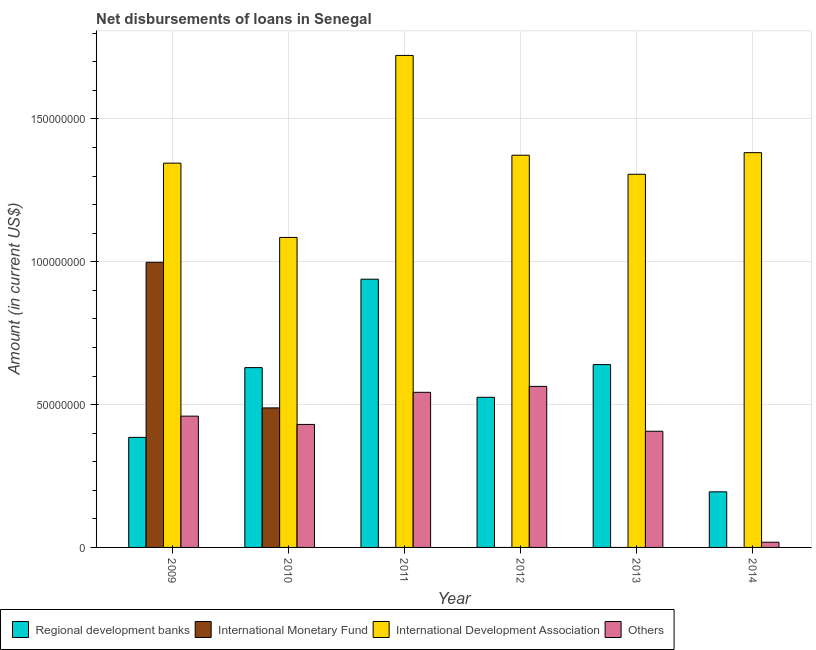Are the number of bars per tick equal to the number of legend labels?
Make the answer very short. No. What is the amount of loan disimbursed by international development association in 2009?
Provide a short and direct response. 1.35e+08. Across all years, what is the maximum amount of loan disimbursed by other organisations?
Your answer should be very brief. 5.64e+07. Across all years, what is the minimum amount of loan disimbursed by regional development banks?
Make the answer very short. 1.95e+07. What is the total amount of loan disimbursed by regional development banks in the graph?
Provide a succinct answer. 3.31e+08. What is the difference between the amount of loan disimbursed by regional development banks in 2012 and that in 2014?
Provide a succinct answer. 3.31e+07. What is the average amount of loan disimbursed by regional development banks per year?
Make the answer very short. 5.52e+07. In the year 2009, what is the difference between the amount of loan disimbursed by other organisations and amount of loan disimbursed by international monetary fund?
Offer a terse response. 0. What is the ratio of the amount of loan disimbursed by international development association in 2011 to that in 2014?
Keep it short and to the point. 1.25. Is the difference between the amount of loan disimbursed by other organisations in 2012 and 2014 greater than the difference between the amount of loan disimbursed by international monetary fund in 2012 and 2014?
Give a very brief answer. No. What is the difference between the highest and the second highest amount of loan disimbursed by international development association?
Offer a very short reply. 3.40e+07. What is the difference between the highest and the lowest amount of loan disimbursed by international development association?
Offer a very short reply. 6.37e+07. In how many years, is the amount of loan disimbursed by international development association greater than the average amount of loan disimbursed by international development association taken over all years?
Keep it short and to the point. 3. Is the sum of the amount of loan disimbursed by international development association in 2012 and 2014 greater than the maximum amount of loan disimbursed by other organisations across all years?
Offer a very short reply. Yes. Are all the bars in the graph horizontal?
Provide a succinct answer. No. How many years are there in the graph?
Provide a short and direct response. 6. What is the difference between two consecutive major ticks on the Y-axis?
Provide a succinct answer. 5.00e+07. Are the values on the major ticks of Y-axis written in scientific E-notation?
Keep it short and to the point. No. Does the graph contain any zero values?
Your response must be concise. Yes. Does the graph contain grids?
Offer a terse response. Yes. How are the legend labels stacked?
Offer a terse response. Horizontal. What is the title of the graph?
Keep it short and to the point. Net disbursements of loans in Senegal. Does "Coal" appear as one of the legend labels in the graph?
Give a very brief answer. No. What is the label or title of the Y-axis?
Your response must be concise. Amount (in current US$). What is the Amount (in current US$) of Regional development banks in 2009?
Your answer should be very brief. 3.85e+07. What is the Amount (in current US$) in International Monetary Fund in 2009?
Offer a very short reply. 9.98e+07. What is the Amount (in current US$) of International Development Association in 2009?
Provide a short and direct response. 1.35e+08. What is the Amount (in current US$) of Others in 2009?
Offer a terse response. 4.60e+07. What is the Amount (in current US$) of Regional development banks in 2010?
Give a very brief answer. 6.30e+07. What is the Amount (in current US$) of International Monetary Fund in 2010?
Provide a short and direct response. 4.88e+07. What is the Amount (in current US$) in International Development Association in 2010?
Offer a very short reply. 1.09e+08. What is the Amount (in current US$) of Others in 2010?
Your answer should be very brief. 4.31e+07. What is the Amount (in current US$) in Regional development banks in 2011?
Make the answer very short. 9.39e+07. What is the Amount (in current US$) in International Monetary Fund in 2011?
Your response must be concise. 0. What is the Amount (in current US$) of International Development Association in 2011?
Your answer should be compact. 1.72e+08. What is the Amount (in current US$) of Others in 2011?
Provide a succinct answer. 5.43e+07. What is the Amount (in current US$) of Regional development banks in 2012?
Your response must be concise. 5.26e+07. What is the Amount (in current US$) in International Development Association in 2012?
Ensure brevity in your answer.  1.37e+08. What is the Amount (in current US$) of Others in 2012?
Ensure brevity in your answer.  5.64e+07. What is the Amount (in current US$) in Regional development banks in 2013?
Offer a terse response. 6.40e+07. What is the Amount (in current US$) of International Development Association in 2013?
Your response must be concise. 1.31e+08. What is the Amount (in current US$) in Others in 2013?
Ensure brevity in your answer.  4.07e+07. What is the Amount (in current US$) of Regional development banks in 2014?
Your answer should be compact. 1.95e+07. What is the Amount (in current US$) in International Development Association in 2014?
Your answer should be very brief. 1.38e+08. What is the Amount (in current US$) of Others in 2014?
Provide a short and direct response. 1.83e+06. Across all years, what is the maximum Amount (in current US$) in Regional development banks?
Your answer should be compact. 9.39e+07. Across all years, what is the maximum Amount (in current US$) of International Monetary Fund?
Ensure brevity in your answer.  9.98e+07. Across all years, what is the maximum Amount (in current US$) of International Development Association?
Your response must be concise. 1.72e+08. Across all years, what is the maximum Amount (in current US$) in Others?
Give a very brief answer. 5.64e+07. Across all years, what is the minimum Amount (in current US$) of Regional development banks?
Make the answer very short. 1.95e+07. Across all years, what is the minimum Amount (in current US$) in International Development Association?
Keep it short and to the point. 1.09e+08. Across all years, what is the minimum Amount (in current US$) in Others?
Your answer should be very brief. 1.83e+06. What is the total Amount (in current US$) of Regional development banks in the graph?
Keep it short and to the point. 3.31e+08. What is the total Amount (in current US$) of International Monetary Fund in the graph?
Your answer should be compact. 1.49e+08. What is the total Amount (in current US$) in International Development Association in the graph?
Give a very brief answer. 8.21e+08. What is the total Amount (in current US$) in Others in the graph?
Give a very brief answer. 2.42e+08. What is the difference between the Amount (in current US$) of Regional development banks in 2009 and that in 2010?
Provide a succinct answer. -2.44e+07. What is the difference between the Amount (in current US$) in International Monetary Fund in 2009 and that in 2010?
Your answer should be very brief. 5.10e+07. What is the difference between the Amount (in current US$) of International Development Association in 2009 and that in 2010?
Offer a very short reply. 2.60e+07. What is the difference between the Amount (in current US$) in Others in 2009 and that in 2010?
Your answer should be very brief. 2.90e+06. What is the difference between the Amount (in current US$) of Regional development banks in 2009 and that in 2011?
Offer a very short reply. -5.54e+07. What is the difference between the Amount (in current US$) of International Development Association in 2009 and that in 2011?
Ensure brevity in your answer.  -3.77e+07. What is the difference between the Amount (in current US$) in Others in 2009 and that in 2011?
Provide a short and direct response. -8.33e+06. What is the difference between the Amount (in current US$) in Regional development banks in 2009 and that in 2012?
Make the answer very short. -1.40e+07. What is the difference between the Amount (in current US$) in International Development Association in 2009 and that in 2012?
Your answer should be compact. -2.77e+06. What is the difference between the Amount (in current US$) in Others in 2009 and that in 2012?
Make the answer very short. -1.04e+07. What is the difference between the Amount (in current US$) in Regional development banks in 2009 and that in 2013?
Offer a very short reply. -2.55e+07. What is the difference between the Amount (in current US$) in International Development Association in 2009 and that in 2013?
Give a very brief answer. 3.91e+06. What is the difference between the Amount (in current US$) of Others in 2009 and that in 2013?
Offer a very short reply. 5.29e+06. What is the difference between the Amount (in current US$) of Regional development banks in 2009 and that in 2014?
Keep it short and to the point. 1.91e+07. What is the difference between the Amount (in current US$) in International Development Association in 2009 and that in 2014?
Your response must be concise. -3.67e+06. What is the difference between the Amount (in current US$) in Others in 2009 and that in 2014?
Keep it short and to the point. 4.41e+07. What is the difference between the Amount (in current US$) in Regional development banks in 2010 and that in 2011?
Keep it short and to the point. -3.10e+07. What is the difference between the Amount (in current US$) in International Development Association in 2010 and that in 2011?
Provide a succinct answer. -6.37e+07. What is the difference between the Amount (in current US$) of Others in 2010 and that in 2011?
Give a very brief answer. -1.12e+07. What is the difference between the Amount (in current US$) of Regional development banks in 2010 and that in 2012?
Keep it short and to the point. 1.04e+07. What is the difference between the Amount (in current US$) of International Development Association in 2010 and that in 2012?
Provide a short and direct response. -2.88e+07. What is the difference between the Amount (in current US$) in Others in 2010 and that in 2012?
Offer a very short reply. -1.33e+07. What is the difference between the Amount (in current US$) of Regional development banks in 2010 and that in 2013?
Keep it short and to the point. -1.06e+06. What is the difference between the Amount (in current US$) in International Development Association in 2010 and that in 2013?
Make the answer very short. -2.21e+07. What is the difference between the Amount (in current US$) in Others in 2010 and that in 2013?
Offer a terse response. 2.39e+06. What is the difference between the Amount (in current US$) in Regional development banks in 2010 and that in 2014?
Make the answer very short. 4.35e+07. What is the difference between the Amount (in current US$) of International Development Association in 2010 and that in 2014?
Make the answer very short. -2.97e+07. What is the difference between the Amount (in current US$) in Others in 2010 and that in 2014?
Your answer should be compact. 4.12e+07. What is the difference between the Amount (in current US$) of Regional development banks in 2011 and that in 2012?
Your answer should be very brief. 4.14e+07. What is the difference between the Amount (in current US$) of International Development Association in 2011 and that in 2012?
Your answer should be compact. 3.49e+07. What is the difference between the Amount (in current US$) of Others in 2011 and that in 2012?
Give a very brief answer. -2.08e+06. What is the difference between the Amount (in current US$) of Regional development banks in 2011 and that in 2013?
Offer a very short reply. 2.99e+07. What is the difference between the Amount (in current US$) of International Development Association in 2011 and that in 2013?
Give a very brief answer. 4.16e+07. What is the difference between the Amount (in current US$) of Others in 2011 and that in 2013?
Offer a terse response. 1.36e+07. What is the difference between the Amount (in current US$) in Regional development banks in 2011 and that in 2014?
Your response must be concise. 7.44e+07. What is the difference between the Amount (in current US$) in International Development Association in 2011 and that in 2014?
Give a very brief answer. 3.40e+07. What is the difference between the Amount (in current US$) of Others in 2011 and that in 2014?
Offer a very short reply. 5.25e+07. What is the difference between the Amount (in current US$) in Regional development banks in 2012 and that in 2013?
Your answer should be very brief. -1.15e+07. What is the difference between the Amount (in current US$) of International Development Association in 2012 and that in 2013?
Keep it short and to the point. 6.68e+06. What is the difference between the Amount (in current US$) in Others in 2012 and that in 2013?
Offer a terse response. 1.57e+07. What is the difference between the Amount (in current US$) of Regional development banks in 2012 and that in 2014?
Your answer should be compact. 3.31e+07. What is the difference between the Amount (in current US$) of International Development Association in 2012 and that in 2014?
Your answer should be very brief. -8.98e+05. What is the difference between the Amount (in current US$) of Others in 2012 and that in 2014?
Offer a terse response. 5.46e+07. What is the difference between the Amount (in current US$) of Regional development banks in 2013 and that in 2014?
Ensure brevity in your answer.  4.45e+07. What is the difference between the Amount (in current US$) in International Development Association in 2013 and that in 2014?
Ensure brevity in your answer.  -7.57e+06. What is the difference between the Amount (in current US$) in Others in 2013 and that in 2014?
Provide a short and direct response. 3.88e+07. What is the difference between the Amount (in current US$) of Regional development banks in 2009 and the Amount (in current US$) of International Monetary Fund in 2010?
Offer a very short reply. -1.03e+07. What is the difference between the Amount (in current US$) of Regional development banks in 2009 and the Amount (in current US$) of International Development Association in 2010?
Ensure brevity in your answer.  -7.00e+07. What is the difference between the Amount (in current US$) in Regional development banks in 2009 and the Amount (in current US$) in Others in 2010?
Ensure brevity in your answer.  -4.53e+06. What is the difference between the Amount (in current US$) of International Monetary Fund in 2009 and the Amount (in current US$) of International Development Association in 2010?
Offer a terse response. -8.70e+06. What is the difference between the Amount (in current US$) in International Monetary Fund in 2009 and the Amount (in current US$) in Others in 2010?
Your response must be concise. 5.68e+07. What is the difference between the Amount (in current US$) in International Development Association in 2009 and the Amount (in current US$) in Others in 2010?
Ensure brevity in your answer.  9.15e+07. What is the difference between the Amount (in current US$) in Regional development banks in 2009 and the Amount (in current US$) in International Development Association in 2011?
Your answer should be compact. -1.34e+08. What is the difference between the Amount (in current US$) in Regional development banks in 2009 and the Amount (in current US$) in Others in 2011?
Ensure brevity in your answer.  -1.58e+07. What is the difference between the Amount (in current US$) in International Monetary Fund in 2009 and the Amount (in current US$) in International Development Association in 2011?
Give a very brief answer. -7.24e+07. What is the difference between the Amount (in current US$) in International Monetary Fund in 2009 and the Amount (in current US$) in Others in 2011?
Your answer should be compact. 4.55e+07. What is the difference between the Amount (in current US$) of International Development Association in 2009 and the Amount (in current US$) of Others in 2011?
Make the answer very short. 8.02e+07. What is the difference between the Amount (in current US$) in Regional development banks in 2009 and the Amount (in current US$) in International Development Association in 2012?
Make the answer very short. -9.88e+07. What is the difference between the Amount (in current US$) in Regional development banks in 2009 and the Amount (in current US$) in Others in 2012?
Your answer should be compact. -1.78e+07. What is the difference between the Amount (in current US$) in International Monetary Fund in 2009 and the Amount (in current US$) in International Development Association in 2012?
Offer a terse response. -3.75e+07. What is the difference between the Amount (in current US$) in International Monetary Fund in 2009 and the Amount (in current US$) in Others in 2012?
Keep it short and to the point. 4.35e+07. What is the difference between the Amount (in current US$) in International Development Association in 2009 and the Amount (in current US$) in Others in 2012?
Make the answer very short. 7.82e+07. What is the difference between the Amount (in current US$) of Regional development banks in 2009 and the Amount (in current US$) of International Development Association in 2013?
Make the answer very short. -9.21e+07. What is the difference between the Amount (in current US$) of Regional development banks in 2009 and the Amount (in current US$) of Others in 2013?
Your answer should be very brief. -2.14e+06. What is the difference between the Amount (in current US$) in International Monetary Fund in 2009 and the Amount (in current US$) in International Development Association in 2013?
Provide a short and direct response. -3.08e+07. What is the difference between the Amount (in current US$) in International Monetary Fund in 2009 and the Amount (in current US$) in Others in 2013?
Your answer should be compact. 5.92e+07. What is the difference between the Amount (in current US$) of International Development Association in 2009 and the Amount (in current US$) of Others in 2013?
Provide a succinct answer. 9.39e+07. What is the difference between the Amount (in current US$) of Regional development banks in 2009 and the Amount (in current US$) of International Development Association in 2014?
Keep it short and to the point. -9.97e+07. What is the difference between the Amount (in current US$) of Regional development banks in 2009 and the Amount (in current US$) of Others in 2014?
Your answer should be compact. 3.67e+07. What is the difference between the Amount (in current US$) of International Monetary Fund in 2009 and the Amount (in current US$) of International Development Association in 2014?
Provide a succinct answer. -3.84e+07. What is the difference between the Amount (in current US$) in International Monetary Fund in 2009 and the Amount (in current US$) in Others in 2014?
Offer a very short reply. 9.80e+07. What is the difference between the Amount (in current US$) in International Development Association in 2009 and the Amount (in current US$) in Others in 2014?
Offer a very short reply. 1.33e+08. What is the difference between the Amount (in current US$) of Regional development banks in 2010 and the Amount (in current US$) of International Development Association in 2011?
Offer a terse response. -1.09e+08. What is the difference between the Amount (in current US$) in Regional development banks in 2010 and the Amount (in current US$) in Others in 2011?
Your answer should be compact. 8.65e+06. What is the difference between the Amount (in current US$) in International Monetary Fund in 2010 and the Amount (in current US$) in International Development Association in 2011?
Your answer should be compact. -1.23e+08. What is the difference between the Amount (in current US$) of International Monetary Fund in 2010 and the Amount (in current US$) of Others in 2011?
Offer a very short reply. -5.45e+06. What is the difference between the Amount (in current US$) in International Development Association in 2010 and the Amount (in current US$) in Others in 2011?
Your answer should be very brief. 5.42e+07. What is the difference between the Amount (in current US$) of Regional development banks in 2010 and the Amount (in current US$) of International Development Association in 2012?
Ensure brevity in your answer.  -7.44e+07. What is the difference between the Amount (in current US$) in Regional development banks in 2010 and the Amount (in current US$) in Others in 2012?
Offer a very short reply. 6.58e+06. What is the difference between the Amount (in current US$) of International Monetary Fund in 2010 and the Amount (in current US$) of International Development Association in 2012?
Ensure brevity in your answer.  -8.85e+07. What is the difference between the Amount (in current US$) of International Monetary Fund in 2010 and the Amount (in current US$) of Others in 2012?
Keep it short and to the point. -7.53e+06. What is the difference between the Amount (in current US$) of International Development Association in 2010 and the Amount (in current US$) of Others in 2012?
Offer a terse response. 5.22e+07. What is the difference between the Amount (in current US$) of Regional development banks in 2010 and the Amount (in current US$) of International Development Association in 2013?
Ensure brevity in your answer.  -6.77e+07. What is the difference between the Amount (in current US$) of Regional development banks in 2010 and the Amount (in current US$) of Others in 2013?
Offer a very short reply. 2.23e+07. What is the difference between the Amount (in current US$) of International Monetary Fund in 2010 and the Amount (in current US$) of International Development Association in 2013?
Provide a short and direct response. -8.18e+07. What is the difference between the Amount (in current US$) in International Monetary Fund in 2010 and the Amount (in current US$) in Others in 2013?
Keep it short and to the point. 8.17e+06. What is the difference between the Amount (in current US$) in International Development Association in 2010 and the Amount (in current US$) in Others in 2013?
Provide a short and direct response. 6.79e+07. What is the difference between the Amount (in current US$) in Regional development banks in 2010 and the Amount (in current US$) in International Development Association in 2014?
Keep it short and to the point. -7.53e+07. What is the difference between the Amount (in current US$) in Regional development banks in 2010 and the Amount (in current US$) in Others in 2014?
Offer a terse response. 6.11e+07. What is the difference between the Amount (in current US$) of International Monetary Fund in 2010 and the Amount (in current US$) of International Development Association in 2014?
Provide a short and direct response. -8.94e+07. What is the difference between the Amount (in current US$) in International Monetary Fund in 2010 and the Amount (in current US$) in Others in 2014?
Keep it short and to the point. 4.70e+07. What is the difference between the Amount (in current US$) in International Development Association in 2010 and the Amount (in current US$) in Others in 2014?
Your answer should be compact. 1.07e+08. What is the difference between the Amount (in current US$) of Regional development banks in 2011 and the Amount (in current US$) of International Development Association in 2012?
Keep it short and to the point. -4.34e+07. What is the difference between the Amount (in current US$) of Regional development banks in 2011 and the Amount (in current US$) of Others in 2012?
Give a very brief answer. 3.75e+07. What is the difference between the Amount (in current US$) in International Development Association in 2011 and the Amount (in current US$) in Others in 2012?
Offer a terse response. 1.16e+08. What is the difference between the Amount (in current US$) in Regional development banks in 2011 and the Amount (in current US$) in International Development Association in 2013?
Keep it short and to the point. -3.67e+07. What is the difference between the Amount (in current US$) of Regional development banks in 2011 and the Amount (in current US$) of Others in 2013?
Provide a succinct answer. 5.32e+07. What is the difference between the Amount (in current US$) of International Development Association in 2011 and the Amount (in current US$) of Others in 2013?
Your answer should be very brief. 1.32e+08. What is the difference between the Amount (in current US$) of Regional development banks in 2011 and the Amount (in current US$) of International Development Association in 2014?
Offer a terse response. -4.43e+07. What is the difference between the Amount (in current US$) of Regional development banks in 2011 and the Amount (in current US$) of Others in 2014?
Keep it short and to the point. 9.21e+07. What is the difference between the Amount (in current US$) of International Development Association in 2011 and the Amount (in current US$) of Others in 2014?
Keep it short and to the point. 1.70e+08. What is the difference between the Amount (in current US$) of Regional development banks in 2012 and the Amount (in current US$) of International Development Association in 2013?
Keep it short and to the point. -7.81e+07. What is the difference between the Amount (in current US$) of Regional development banks in 2012 and the Amount (in current US$) of Others in 2013?
Offer a very short reply. 1.19e+07. What is the difference between the Amount (in current US$) in International Development Association in 2012 and the Amount (in current US$) in Others in 2013?
Provide a short and direct response. 9.66e+07. What is the difference between the Amount (in current US$) of Regional development banks in 2012 and the Amount (in current US$) of International Development Association in 2014?
Your answer should be very brief. -8.56e+07. What is the difference between the Amount (in current US$) in Regional development banks in 2012 and the Amount (in current US$) in Others in 2014?
Offer a very short reply. 5.07e+07. What is the difference between the Amount (in current US$) of International Development Association in 2012 and the Amount (in current US$) of Others in 2014?
Keep it short and to the point. 1.35e+08. What is the difference between the Amount (in current US$) of Regional development banks in 2013 and the Amount (in current US$) of International Development Association in 2014?
Provide a short and direct response. -7.42e+07. What is the difference between the Amount (in current US$) in Regional development banks in 2013 and the Amount (in current US$) in Others in 2014?
Your response must be concise. 6.22e+07. What is the difference between the Amount (in current US$) of International Development Association in 2013 and the Amount (in current US$) of Others in 2014?
Your answer should be very brief. 1.29e+08. What is the average Amount (in current US$) of Regional development banks per year?
Offer a terse response. 5.52e+07. What is the average Amount (in current US$) in International Monetary Fund per year?
Ensure brevity in your answer.  2.48e+07. What is the average Amount (in current US$) in International Development Association per year?
Ensure brevity in your answer.  1.37e+08. What is the average Amount (in current US$) in Others per year?
Offer a very short reply. 4.04e+07. In the year 2009, what is the difference between the Amount (in current US$) of Regional development banks and Amount (in current US$) of International Monetary Fund?
Your answer should be very brief. -6.13e+07. In the year 2009, what is the difference between the Amount (in current US$) of Regional development banks and Amount (in current US$) of International Development Association?
Offer a terse response. -9.60e+07. In the year 2009, what is the difference between the Amount (in current US$) in Regional development banks and Amount (in current US$) in Others?
Your answer should be compact. -7.44e+06. In the year 2009, what is the difference between the Amount (in current US$) in International Monetary Fund and Amount (in current US$) in International Development Association?
Offer a very short reply. -3.47e+07. In the year 2009, what is the difference between the Amount (in current US$) of International Monetary Fund and Amount (in current US$) of Others?
Provide a succinct answer. 5.39e+07. In the year 2009, what is the difference between the Amount (in current US$) of International Development Association and Amount (in current US$) of Others?
Give a very brief answer. 8.86e+07. In the year 2010, what is the difference between the Amount (in current US$) of Regional development banks and Amount (in current US$) of International Monetary Fund?
Keep it short and to the point. 1.41e+07. In the year 2010, what is the difference between the Amount (in current US$) of Regional development banks and Amount (in current US$) of International Development Association?
Offer a very short reply. -4.56e+07. In the year 2010, what is the difference between the Amount (in current US$) in Regional development banks and Amount (in current US$) in Others?
Keep it short and to the point. 1.99e+07. In the year 2010, what is the difference between the Amount (in current US$) in International Monetary Fund and Amount (in current US$) in International Development Association?
Provide a short and direct response. -5.97e+07. In the year 2010, what is the difference between the Amount (in current US$) of International Monetary Fund and Amount (in current US$) of Others?
Your response must be concise. 5.79e+06. In the year 2010, what is the difference between the Amount (in current US$) in International Development Association and Amount (in current US$) in Others?
Your answer should be very brief. 6.55e+07. In the year 2011, what is the difference between the Amount (in current US$) in Regional development banks and Amount (in current US$) in International Development Association?
Give a very brief answer. -7.83e+07. In the year 2011, what is the difference between the Amount (in current US$) in Regional development banks and Amount (in current US$) in Others?
Offer a terse response. 3.96e+07. In the year 2011, what is the difference between the Amount (in current US$) of International Development Association and Amount (in current US$) of Others?
Keep it short and to the point. 1.18e+08. In the year 2012, what is the difference between the Amount (in current US$) of Regional development banks and Amount (in current US$) of International Development Association?
Make the answer very short. -8.48e+07. In the year 2012, what is the difference between the Amount (in current US$) in Regional development banks and Amount (in current US$) in Others?
Provide a succinct answer. -3.82e+06. In the year 2012, what is the difference between the Amount (in current US$) in International Development Association and Amount (in current US$) in Others?
Your answer should be very brief. 8.09e+07. In the year 2013, what is the difference between the Amount (in current US$) of Regional development banks and Amount (in current US$) of International Development Association?
Offer a very short reply. -6.66e+07. In the year 2013, what is the difference between the Amount (in current US$) in Regional development banks and Amount (in current US$) in Others?
Your answer should be very brief. 2.33e+07. In the year 2013, what is the difference between the Amount (in current US$) of International Development Association and Amount (in current US$) of Others?
Give a very brief answer. 9.00e+07. In the year 2014, what is the difference between the Amount (in current US$) of Regional development banks and Amount (in current US$) of International Development Association?
Make the answer very short. -1.19e+08. In the year 2014, what is the difference between the Amount (in current US$) in Regional development banks and Amount (in current US$) in Others?
Provide a short and direct response. 1.76e+07. In the year 2014, what is the difference between the Amount (in current US$) in International Development Association and Amount (in current US$) in Others?
Your response must be concise. 1.36e+08. What is the ratio of the Amount (in current US$) in Regional development banks in 2009 to that in 2010?
Offer a terse response. 0.61. What is the ratio of the Amount (in current US$) in International Monetary Fund in 2009 to that in 2010?
Offer a very short reply. 2.04. What is the ratio of the Amount (in current US$) in International Development Association in 2009 to that in 2010?
Ensure brevity in your answer.  1.24. What is the ratio of the Amount (in current US$) in Others in 2009 to that in 2010?
Give a very brief answer. 1.07. What is the ratio of the Amount (in current US$) in Regional development banks in 2009 to that in 2011?
Provide a succinct answer. 0.41. What is the ratio of the Amount (in current US$) in International Development Association in 2009 to that in 2011?
Give a very brief answer. 0.78. What is the ratio of the Amount (in current US$) of Others in 2009 to that in 2011?
Offer a terse response. 0.85. What is the ratio of the Amount (in current US$) in Regional development banks in 2009 to that in 2012?
Your answer should be compact. 0.73. What is the ratio of the Amount (in current US$) in International Development Association in 2009 to that in 2012?
Keep it short and to the point. 0.98. What is the ratio of the Amount (in current US$) in Others in 2009 to that in 2012?
Offer a terse response. 0.82. What is the ratio of the Amount (in current US$) in Regional development banks in 2009 to that in 2013?
Your answer should be compact. 0.6. What is the ratio of the Amount (in current US$) in International Development Association in 2009 to that in 2013?
Ensure brevity in your answer.  1.03. What is the ratio of the Amount (in current US$) of Others in 2009 to that in 2013?
Ensure brevity in your answer.  1.13. What is the ratio of the Amount (in current US$) of Regional development banks in 2009 to that in 2014?
Make the answer very short. 1.98. What is the ratio of the Amount (in current US$) of International Development Association in 2009 to that in 2014?
Provide a succinct answer. 0.97. What is the ratio of the Amount (in current US$) in Others in 2009 to that in 2014?
Ensure brevity in your answer.  25.17. What is the ratio of the Amount (in current US$) in Regional development banks in 2010 to that in 2011?
Your answer should be very brief. 0.67. What is the ratio of the Amount (in current US$) in International Development Association in 2010 to that in 2011?
Provide a succinct answer. 0.63. What is the ratio of the Amount (in current US$) of Others in 2010 to that in 2011?
Keep it short and to the point. 0.79. What is the ratio of the Amount (in current US$) in Regional development banks in 2010 to that in 2012?
Offer a very short reply. 1.2. What is the ratio of the Amount (in current US$) of International Development Association in 2010 to that in 2012?
Your answer should be compact. 0.79. What is the ratio of the Amount (in current US$) in Others in 2010 to that in 2012?
Make the answer very short. 0.76. What is the ratio of the Amount (in current US$) of Regional development banks in 2010 to that in 2013?
Make the answer very short. 0.98. What is the ratio of the Amount (in current US$) of International Development Association in 2010 to that in 2013?
Provide a short and direct response. 0.83. What is the ratio of the Amount (in current US$) of Others in 2010 to that in 2013?
Your answer should be compact. 1.06. What is the ratio of the Amount (in current US$) of Regional development banks in 2010 to that in 2014?
Make the answer very short. 3.23. What is the ratio of the Amount (in current US$) of International Development Association in 2010 to that in 2014?
Keep it short and to the point. 0.79. What is the ratio of the Amount (in current US$) in Others in 2010 to that in 2014?
Ensure brevity in your answer.  23.58. What is the ratio of the Amount (in current US$) of Regional development banks in 2011 to that in 2012?
Your answer should be very brief. 1.79. What is the ratio of the Amount (in current US$) of International Development Association in 2011 to that in 2012?
Offer a very short reply. 1.25. What is the ratio of the Amount (in current US$) of Others in 2011 to that in 2012?
Your response must be concise. 0.96. What is the ratio of the Amount (in current US$) in Regional development banks in 2011 to that in 2013?
Provide a short and direct response. 1.47. What is the ratio of the Amount (in current US$) of International Development Association in 2011 to that in 2013?
Provide a short and direct response. 1.32. What is the ratio of the Amount (in current US$) of Others in 2011 to that in 2013?
Give a very brief answer. 1.33. What is the ratio of the Amount (in current US$) of Regional development banks in 2011 to that in 2014?
Offer a terse response. 4.83. What is the ratio of the Amount (in current US$) of International Development Association in 2011 to that in 2014?
Provide a short and direct response. 1.25. What is the ratio of the Amount (in current US$) in Others in 2011 to that in 2014?
Make the answer very short. 29.74. What is the ratio of the Amount (in current US$) of Regional development banks in 2012 to that in 2013?
Keep it short and to the point. 0.82. What is the ratio of the Amount (in current US$) of International Development Association in 2012 to that in 2013?
Provide a succinct answer. 1.05. What is the ratio of the Amount (in current US$) of Others in 2012 to that in 2013?
Offer a very short reply. 1.39. What is the ratio of the Amount (in current US$) of Regional development banks in 2012 to that in 2014?
Offer a terse response. 2.7. What is the ratio of the Amount (in current US$) of Others in 2012 to that in 2014?
Ensure brevity in your answer.  30.88. What is the ratio of the Amount (in current US$) in Regional development banks in 2013 to that in 2014?
Make the answer very short. 3.29. What is the ratio of the Amount (in current US$) of International Development Association in 2013 to that in 2014?
Your answer should be compact. 0.95. What is the ratio of the Amount (in current US$) of Others in 2013 to that in 2014?
Make the answer very short. 22.28. What is the difference between the highest and the second highest Amount (in current US$) in Regional development banks?
Ensure brevity in your answer.  2.99e+07. What is the difference between the highest and the second highest Amount (in current US$) of International Development Association?
Offer a terse response. 3.40e+07. What is the difference between the highest and the second highest Amount (in current US$) of Others?
Your answer should be very brief. 2.08e+06. What is the difference between the highest and the lowest Amount (in current US$) in Regional development banks?
Keep it short and to the point. 7.44e+07. What is the difference between the highest and the lowest Amount (in current US$) of International Monetary Fund?
Your answer should be very brief. 9.98e+07. What is the difference between the highest and the lowest Amount (in current US$) of International Development Association?
Make the answer very short. 6.37e+07. What is the difference between the highest and the lowest Amount (in current US$) in Others?
Offer a terse response. 5.46e+07. 